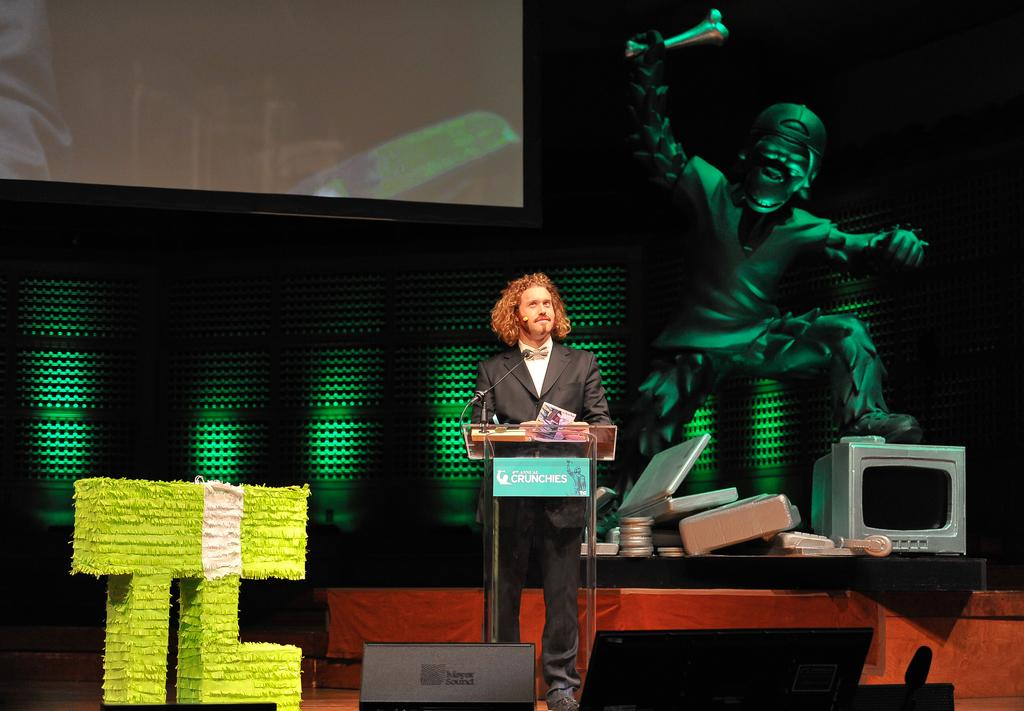<image>
Offer a succinct explanation of the picture presented. a man speaking at a podium with the words CRUNCHIES on it 